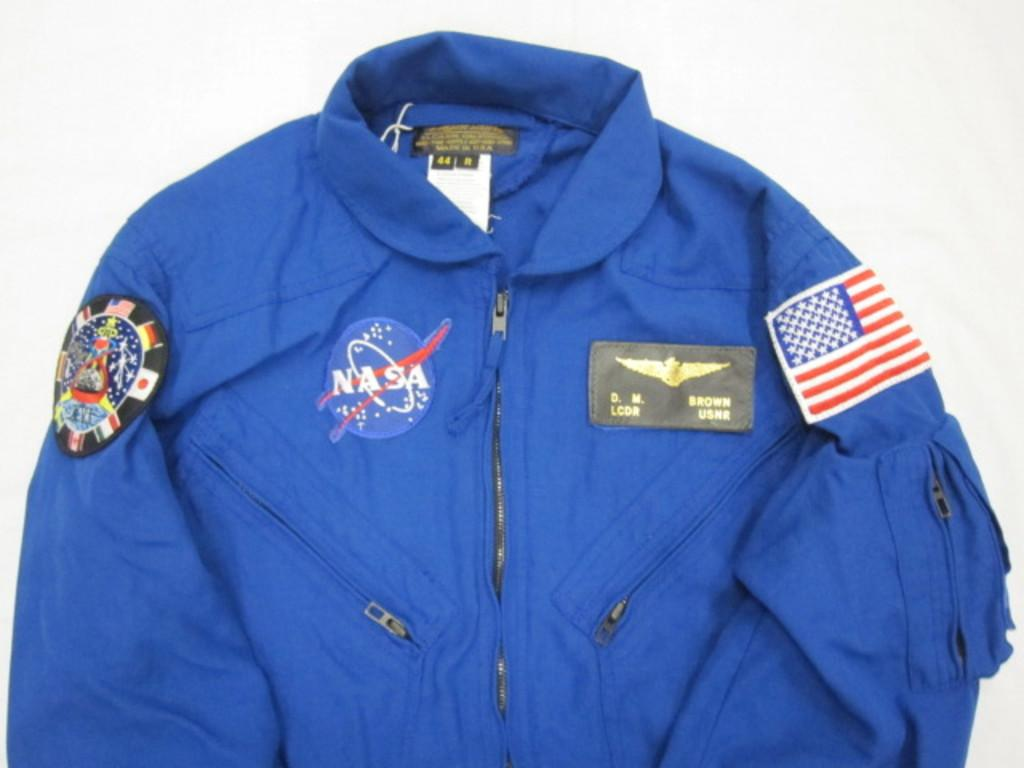<image>
Give a short and clear explanation of the subsequent image. the name NASA that is on a jacket 